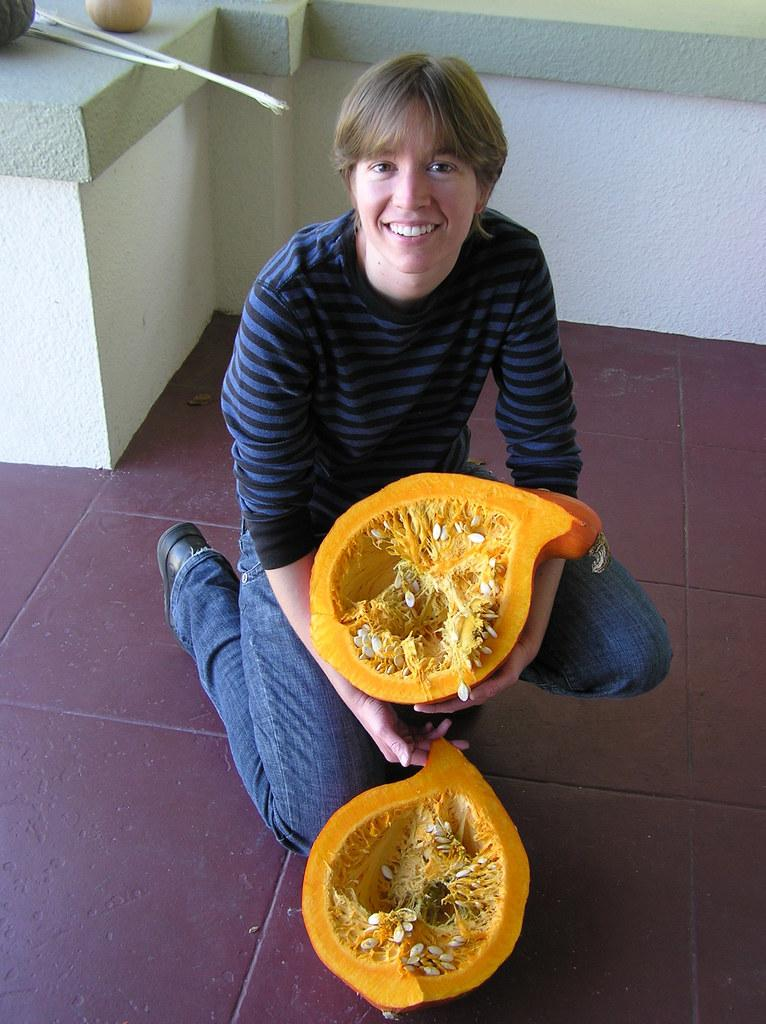What is the person in the image doing? The person is sitting on the floor in the image. What object is the person holding? The person is holding a pumpkin. What can be seen in the background of the image? There is a wall in the background of the image. What is attached to the wall? There are sticks and vegetables on the wall. What type of skirt is the person wearing in the image? The person is sitting on the floor, and there is no mention of a skirt in the provided facts, so we cannot determine the type of skirt the person is wearing. 